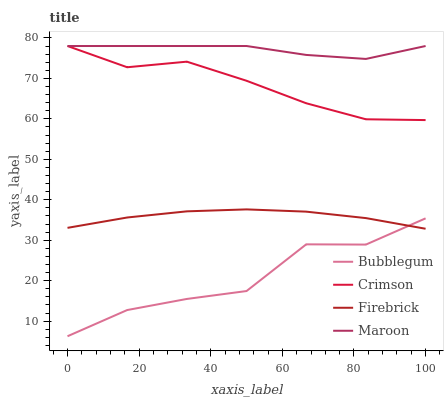Does Bubblegum have the minimum area under the curve?
Answer yes or no. Yes. Does Maroon have the maximum area under the curve?
Answer yes or no. Yes. Does Firebrick have the minimum area under the curve?
Answer yes or no. No. Does Firebrick have the maximum area under the curve?
Answer yes or no. No. Is Firebrick the smoothest?
Answer yes or no. Yes. Is Bubblegum the roughest?
Answer yes or no. Yes. Is Maroon the smoothest?
Answer yes or no. No. Is Maroon the roughest?
Answer yes or no. No. Does Bubblegum have the lowest value?
Answer yes or no. Yes. Does Firebrick have the lowest value?
Answer yes or no. No. Does Maroon have the highest value?
Answer yes or no. Yes. Does Firebrick have the highest value?
Answer yes or no. No. Is Firebrick less than Maroon?
Answer yes or no. Yes. Is Crimson greater than Firebrick?
Answer yes or no. Yes. Does Crimson intersect Maroon?
Answer yes or no. Yes. Is Crimson less than Maroon?
Answer yes or no. No. Is Crimson greater than Maroon?
Answer yes or no. No. Does Firebrick intersect Maroon?
Answer yes or no. No. 